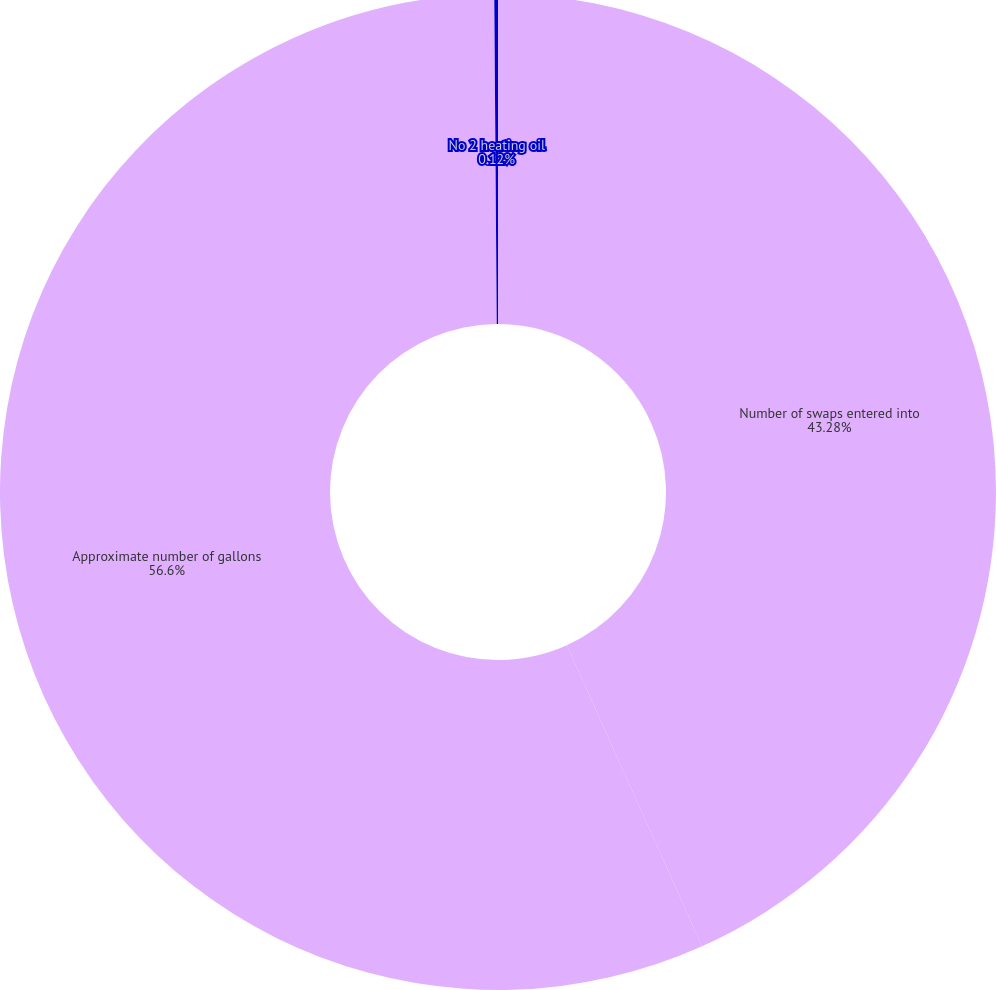<chart> <loc_0><loc_0><loc_500><loc_500><pie_chart><fcel>Number of swaps entered into<fcel>Approximate number of gallons<fcel>No 2 heating oil<nl><fcel>43.28%<fcel>56.6%<fcel>0.12%<nl></chart> 